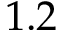Convert formula to latex. <formula><loc_0><loc_0><loc_500><loc_500>1 . 2</formula> 